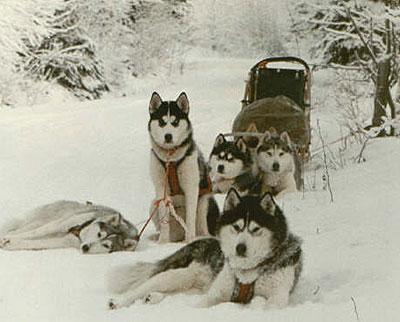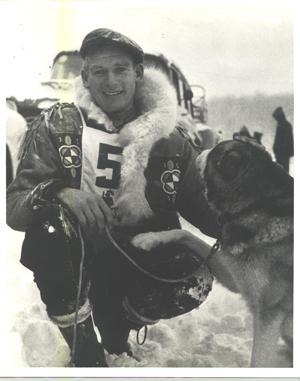The first image is the image on the left, the second image is the image on the right. Assess this claim about the two images: "A person bundled in fur for warm is posing behind one sled dog in the right image.". Correct or not? Answer yes or no. Yes. The first image is the image on the left, the second image is the image on the right. Considering the images on both sides, is "In at least one image there is  a single sled dog with it's owner posing behind them." valid? Answer yes or no. Yes. 